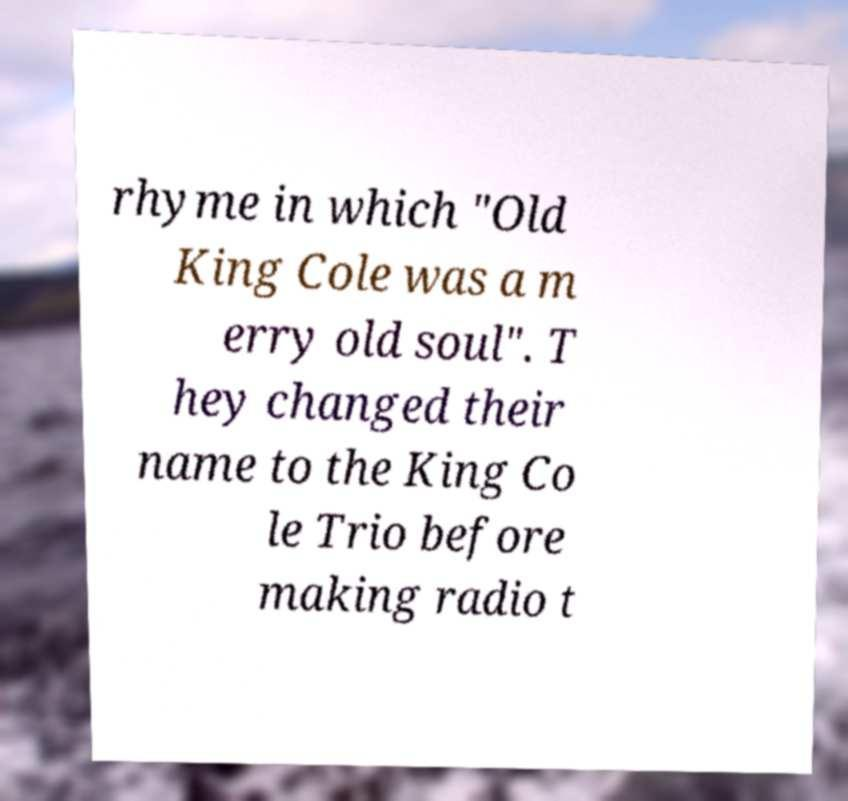What messages or text are displayed in this image? I need them in a readable, typed format. rhyme in which "Old King Cole was a m erry old soul". T hey changed their name to the King Co le Trio before making radio t 